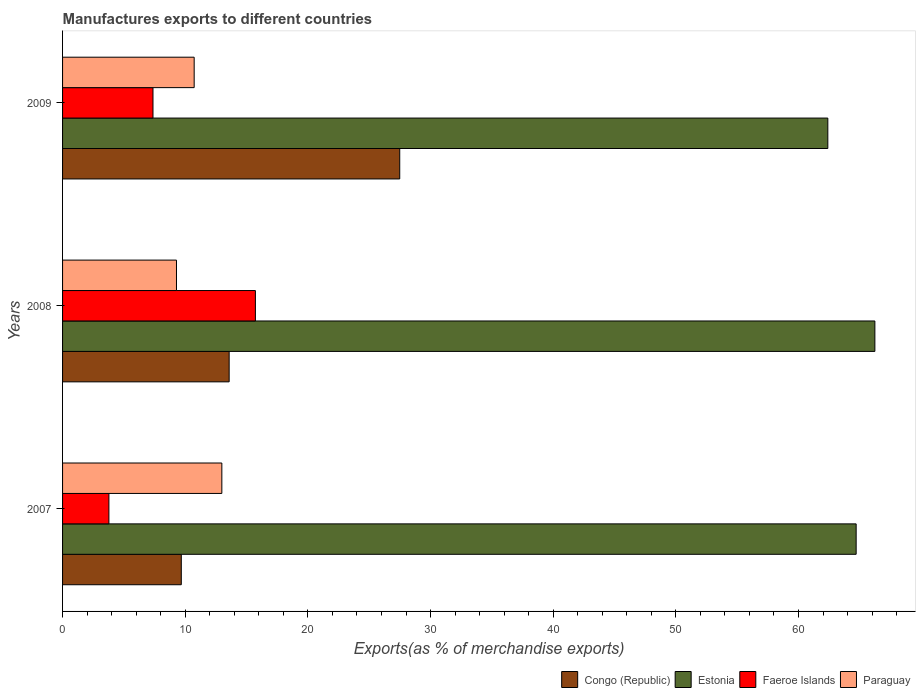How many different coloured bars are there?
Ensure brevity in your answer.  4. Are the number of bars on each tick of the Y-axis equal?
Give a very brief answer. Yes. How many bars are there on the 1st tick from the bottom?
Ensure brevity in your answer.  4. What is the label of the 1st group of bars from the top?
Provide a succinct answer. 2009. What is the percentage of exports to different countries in Congo (Republic) in 2007?
Your answer should be compact. 9.68. Across all years, what is the maximum percentage of exports to different countries in Congo (Republic)?
Your answer should be compact. 27.49. Across all years, what is the minimum percentage of exports to different countries in Congo (Republic)?
Keep it short and to the point. 9.68. In which year was the percentage of exports to different countries in Faeroe Islands maximum?
Your answer should be compact. 2008. What is the total percentage of exports to different countries in Paraguay in the graph?
Your answer should be compact. 33. What is the difference between the percentage of exports to different countries in Estonia in 2007 and that in 2009?
Make the answer very short. 2.31. What is the difference between the percentage of exports to different countries in Congo (Republic) in 2009 and the percentage of exports to different countries in Paraguay in 2007?
Provide a succinct answer. 14.5. What is the average percentage of exports to different countries in Faeroe Islands per year?
Keep it short and to the point. 8.96. In the year 2009, what is the difference between the percentage of exports to different countries in Faeroe Islands and percentage of exports to different countries in Estonia?
Keep it short and to the point. -55.02. What is the ratio of the percentage of exports to different countries in Faeroe Islands in 2007 to that in 2009?
Keep it short and to the point. 0.51. Is the percentage of exports to different countries in Paraguay in 2008 less than that in 2009?
Provide a succinct answer. Yes. Is the difference between the percentage of exports to different countries in Faeroe Islands in 2008 and 2009 greater than the difference between the percentage of exports to different countries in Estonia in 2008 and 2009?
Provide a short and direct response. Yes. What is the difference between the highest and the second highest percentage of exports to different countries in Congo (Republic)?
Your answer should be compact. 13.91. What is the difference between the highest and the lowest percentage of exports to different countries in Estonia?
Offer a terse response. 3.84. Is the sum of the percentage of exports to different countries in Congo (Republic) in 2007 and 2008 greater than the maximum percentage of exports to different countries in Paraguay across all years?
Your answer should be very brief. Yes. Is it the case that in every year, the sum of the percentage of exports to different countries in Congo (Republic) and percentage of exports to different countries in Estonia is greater than the sum of percentage of exports to different countries in Faeroe Islands and percentage of exports to different countries in Paraguay?
Make the answer very short. No. What does the 2nd bar from the top in 2009 represents?
Offer a very short reply. Faeroe Islands. What does the 1st bar from the bottom in 2009 represents?
Keep it short and to the point. Congo (Republic). Is it the case that in every year, the sum of the percentage of exports to different countries in Congo (Republic) and percentage of exports to different countries in Paraguay is greater than the percentage of exports to different countries in Faeroe Islands?
Provide a short and direct response. Yes. How many bars are there?
Your response must be concise. 12. Are the values on the major ticks of X-axis written in scientific E-notation?
Keep it short and to the point. No. Does the graph contain grids?
Offer a very short reply. No. How many legend labels are there?
Your answer should be very brief. 4. What is the title of the graph?
Offer a terse response. Manufactures exports to different countries. What is the label or title of the X-axis?
Offer a very short reply. Exports(as % of merchandise exports). What is the Exports(as % of merchandise exports) of Congo (Republic) in 2007?
Give a very brief answer. 9.68. What is the Exports(as % of merchandise exports) of Estonia in 2007?
Your response must be concise. 64.7. What is the Exports(as % of merchandise exports) of Faeroe Islands in 2007?
Make the answer very short. 3.78. What is the Exports(as % of merchandise exports) in Paraguay in 2007?
Your response must be concise. 12.99. What is the Exports(as % of merchandise exports) in Congo (Republic) in 2008?
Your response must be concise. 13.58. What is the Exports(as % of merchandise exports) in Estonia in 2008?
Your answer should be very brief. 66.23. What is the Exports(as % of merchandise exports) in Faeroe Islands in 2008?
Provide a succinct answer. 15.72. What is the Exports(as % of merchandise exports) in Paraguay in 2008?
Your answer should be very brief. 9.29. What is the Exports(as % of merchandise exports) in Congo (Republic) in 2009?
Your response must be concise. 27.49. What is the Exports(as % of merchandise exports) in Estonia in 2009?
Make the answer very short. 62.39. What is the Exports(as % of merchandise exports) of Faeroe Islands in 2009?
Provide a succinct answer. 7.37. What is the Exports(as % of merchandise exports) of Paraguay in 2009?
Offer a terse response. 10.73. Across all years, what is the maximum Exports(as % of merchandise exports) of Congo (Republic)?
Offer a very short reply. 27.49. Across all years, what is the maximum Exports(as % of merchandise exports) in Estonia?
Your response must be concise. 66.23. Across all years, what is the maximum Exports(as % of merchandise exports) in Faeroe Islands?
Provide a succinct answer. 15.72. Across all years, what is the maximum Exports(as % of merchandise exports) of Paraguay?
Your answer should be very brief. 12.99. Across all years, what is the minimum Exports(as % of merchandise exports) in Congo (Republic)?
Make the answer very short. 9.68. Across all years, what is the minimum Exports(as % of merchandise exports) of Estonia?
Your response must be concise. 62.39. Across all years, what is the minimum Exports(as % of merchandise exports) in Faeroe Islands?
Offer a very short reply. 3.78. Across all years, what is the minimum Exports(as % of merchandise exports) in Paraguay?
Provide a succinct answer. 9.29. What is the total Exports(as % of merchandise exports) of Congo (Republic) in the graph?
Make the answer very short. 50.75. What is the total Exports(as % of merchandise exports) in Estonia in the graph?
Your answer should be compact. 193.32. What is the total Exports(as % of merchandise exports) of Faeroe Islands in the graph?
Your response must be concise. 26.87. What is the total Exports(as % of merchandise exports) in Paraguay in the graph?
Offer a terse response. 33. What is the difference between the Exports(as % of merchandise exports) in Congo (Republic) in 2007 and that in 2008?
Provide a short and direct response. -3.9. What is the difference between the Exports(as % of merchandise exports) in Estonia in 2007 and that in 2008?
Make the answer very short. -1.53. What is the difference between the Exports(as % of merchandise exports) in Faeroe Islands in 2007 and that in 2008?
Your answer should be very brief. -11.94. What is the difference between the Exports(as % of merchandise exports) of Paraguay in 2007 and that in 2008?
Provide a succinct answer. 3.7. What is the difference between the Exports(as % of merchandise exports) of Congo (Republic) in 2007 and that in 2009?
Give a very brief answer. -17.81. What is the difference between the Exports(as % of merchandise exports) in Estonia in 2007 and that in 2009?
Your answer should be very brief. 2.31. What is the difference between the Exports(as % of merchandise exports) of Faeroe Islands in 2007 and that in 2009?
Your answer should be compact. -3.59. What is the difference between the Exports(as % of merchandise exports) in Paraguay in 2007 and that in 2009?
Offer a terse response. 2.26. What is the difference between the Exports(as % of merchandise exports) in Congo (Republic) in 2008 and that in 2009?
Provide a short and direct response. -13.91. What is the difference between the Exports(as % of merchandise exports) in Estonia in 2008 and that in 2009?
Give a very brief answer. 3.84. What is the difference between the Exports(as % of merchandise exports) of Faeroe Islands in 2008 and that in 2009?
Provide a succinct answer. 8.35. What is the difference between the Exports(as % of merchandise exports) in Paraguay in 2008 and that in 2009?
Ensure brevity in your answer.  -1.44. What is the difference between the Exports(as % of merchandise exports) of Congo (Republic) in 2007 and the Exports(as % of merchandise exports) of Estonia in 2008?
Provide a succinct answer. -56.55. What is the difference between the Exports(as % of merchandise exports) in Congo (Republic) in 2007 and the Exports(as % of merchandise exports) in Faeroe Islands in 2008?
Give a very brief answer. -6.04. What is the difference between the Exports(as % of merchandise exports) in Congo (Republic) in 2007 and the Exports(as % of merchandise exports) in Paraguay in 2008?
Your answer should be compact. 0.39. What is the difference between the Exports(as % of merchandise exports) of Estonia in 2007 and the Exports(as % of merchandise exports) of Faeroe Islands in 2008?
Keep it short and to the point. 48.98. What is the difference between the Exports(as % of merchandise exports) of Estonia in 2007 and the Exports(as % of merchandise exports) of Paraguay in 2008?
Your response must be concise. 55.41. What is the difference between the Exports(as % of merchandise exports) in Faeroe Islands in 2007 and the Exports(as % of merchandise exports) in Paraguay in 2008?
Provide a short and direct response. -5.51. What is the difference between the Exports(as % of merchandise exports) of Congo (Republic) in 2007 and the Exports(as % of merchandise exports) of Estonia in 2009?
Offer a terse response. -52.71. What is the difference between the Exports(as % of merchandise exports) in Congo (Republic) in 2007 and the Exports(as % of merchandise exports) in Faeroe Islands in 2009?
Ensure brevity in your answer.  2.31. What is the difference between the Exports(as % of merchandise exports) in Congo (Republic) in 2007 and the Exports(as % of merchandise exports) in Paraguay in 2009?
Your answer should be compact. -1.05. What is the difference between the Exports(as % of merchandise exports) in Estonia in 2007 and the Exports(as % of merchandise exports) in Faeroe Islands in 2009?
Provide a short and direct response. 57.33. What is the difference between the Exports(as % of merchandise exports) in Estonia in 2007 and the Exports(as % of merchandise exports) in Paraguay in 2009?
Your answer should be very brief. 53.97. What is the difference between the Exports(as % of merchandise exports) in Faeroe Islands in 2007 and the Exports(as % of merchandise exports) in Paraguay in 2009?
Ensure brevity in your answer.  -6.95. What is the difference between the Exports(as % of merchandise exports) of Congo (Republic) in 2008 and the Exports(as % of merchandise exports) of Estonia in 2009?
Keep it short and to the point. -48.81. What is the difference between the Exports(as % of merchandise exports) in Congo (Republic) in 2008 and the Exports(as % of merchandise exports) in Faeroe Islands in 2009?
Offer a very short reply. 6.21. What is the difference between the Exports(as % of merchandise exports) of Congo (Republic) in 2008 and the Exports(as % of merchandise exports) of Paraguay in 2009?
Your answer should be compact. 2.85. What is the difference between the Exports(as % of merchandise exports) in Estonia in 2008 and the Exports(as % of merchandise exports) in Faeroe Islands in 2009?
Provide a short and direct response. 58.86. What is the difference between the Exports(as % of merchandise exports) of Estonia in 2008 and the Exports(as % of merchandise exports) of Paraguay in 2009?
Keep it short and to the point. 55.5. What is the difference between the Exports(as % of merchandise exports) of Faeroe Islands in 2008 and the Exports(as % of merchandise exports) of Paraguay in 2009?
Ensure brevity in your answer.  4.99. What is the average Exports(as % of merchandise exports) in Congo (Republic) per year?
Your answer should be very brief. 16.92. What is the average Exports(as % of merchandise exports) of Estonia per year?
Provide a short and direct response. 64.44. What is the average Exports(as % of merchandise exports) in Faeroe Islands per year?
Offer a very short reply. 8.96. What is the average Exports(as % of merchandise exports) in Paraguay per year?
Ensure brevity in your answer.  11. In the year 2007, what is the difference between the Exports(as % of merchandise exports) of Congo (Republic) and Exports(as % of merchandise exports) of Estonia?
Your answer should be compact. -55.02. In the year 2007, what is the difference between the Exports(as % of merchandise exports) in Congo (Republic) and Exports(as % of merchandise exports) in Faeroe Islands?
Provide a short and direct response. 5.9. In the year 2007, what is the difference between the Exports(as % of merchandise exports) in Congo (Republic) and Exports(as % of merchandise exports) in Paraguay?
Provide a short and direct response. -3.31. In the year 2007, what is the difference between the Exports(as % of merchandise exports) of Estonia and Exports(as % of merchandise exports) of Faeroe Islands?
Your answer should be very brief. 60.92. In the year 2007, what is the difference between the Exports(as % of merchandise exports) in Estonia and Exports(as % of merchandise exports) in Paraguay?
Ensure brevity in your answer.  51.72. In the year 2007, what is the difference between the Exports(as % of merchandise exports) in Faeroe Islands and Exports(as % of merchandise exports) in Paraguay?
Provide a short and direct response. -9.21. In the year 2008, what is the difference between the Exports(as % of merchandise exports) of Congo (Republic) and Exports(as % of merchandise exports) of Estonia?
Your answer should be compact. -52.65. In the year 2008, what is the difference between the Exports(as % of merchandise exports) in Congo (Republic) and Exports(as % of merchandise exports) in Faeroe Islands?
Keep it short and to the point. -2.14. In the year 2008, what is the difference between the Exports(as % of merchandise exports) in Congo (Republic) and Exports(as % of merchandise exports) in Paraguay?
Keep it short and to the point. 4.29. In the year 2008, what is the difference between the Exports(as % of merchandise exports) in Estonia and Exports(as % of merchandise exports) in Faeroe Islands?
Make the answer very short. 50.51. In the year 2008, what is the difference between the Exports(as % of merchandise exports) in Estonia and Exports(as % of merchandise exports) in Paraguay?
Your answer should be compact. 56.94. In the year 2008, what is the difference between the Exports(as % of merchandise exports) in Faeroe Islands and Exports(as % of merchandise exports) in Paraguay?
Ensure brevity in your answer.  6.44. In the year 2009, what is the difference between the Exports(as % of merchandise exports) of Congo (Republic) and Exports(as % of merchandise exports) of Estonia?
Ensure brevity in your answer.  -34.9. In the year 2009, what is the difference between the Exports(as % of merchandise exports) of Congo (Republic) and Exports(as % of merchandise exports) of Faeroe Islands?
Give a very brief answer. 20.12. In the year 2009, what is the difference between the Exports(as % of merchandise exports) in Congo (Republic) and Exports(as % of merchandise exports) in Paraguay?
Give a very brief answer. 16.76. In the year 2009, what is the difference between the Exports(as % of merchandise exports) in Estonia and Exports(as % of merchandise exports) in Faeroe Islands?
Keep it short and to the point. 55.02. In the year 2009, what is the difference between the Exports(as % of merchandise exports) of Estonia and Exports(as % of merchandise exports) of Paraguay?
Provide a short and direct response. 51.66. In the year 2009, what is the difference between the Exports(as % of merchandise exports) of Faeroe Islands and Exports(as % of merchandise exports) of Paraguay?
Your answer should be compact. -3.36. What is the ratio of the Exports(as % of merchandise exports) in Congo (Republic) in 2007 to that in 2008?
Provide a short and direct response. 0.71. What is the ratio of the Exports(as % of merchandise exports) of Estonia in 2007 to that in 2008?
Ensure brevity in your answer.  0.98. What is the ratio of the Exports(as % of merchandise exports) of Faeroe Islands in 2007 to that in 2008?
Offer a terse response. 0.24. What is the ratio of the Exports(as % of merchandise exports) of Paraguay in 2007 to that in 2008?
Provide a succinct answer. 1.4. What is the ratio of the Exports(as % of merchandise exports) in Congo (Republic) in 2007 to that in 2009?
Provide a short and direct response. 0.35. What is the ratio of the Exports(as % of merchandise exports) of Estonia in 2007 to that in 2009?
Provide a short and direct response. 1.04. What is the ratio of the Exports(as % of merchandise exports) in Faeroe Islands in 2007 to that in 2009?
Your answer should be very brief. 0.51. What is the ratio of the Exports(as % of merchandise exports) in Paraguay in 2007 to that in 2009?
Keep it short and to the point. 1.21. What is the ratio of the Exports(as % of merchandise exports) in Congo (Republic) in 2008 to that in 2009?
Your response must be concise. 0.49. What is the ratio of the Exports(as % of merchandise exports) in Estonia in 2008 to that in 2009?
Keep it short and to the point. 1.06. What is the ratio of the Exports(as % of merchandise exports) of Faeroe Islands in 2008 to that in 2009?
Offer a very short reply. 2.13. What is the ratio of the Exports(as % of merchandise exports) of Paraguay in 2008 to that in 2009?
Offer a very short reply. 0.87. What is the difference between the highest and the second highest Exports(as % of merchandise exports) in Congo (Republic)?
Ensure brevity in your answer.  13.91. What is the difference between the highest and the second highest Exports(as % of merchandise exports) in Estonia?
Your answer should be compact. 1.53. What is the difference between the highest and the second highest Exports(as % of merchandise exports) in Faeroe Islands?
Your response must be concise. 8.35. What is the difference between the highest and the second highest Exports(as % of merchandise exports) in Paraguay?
Keep it short and to the point. 2.26. What is the difference between the highest and the lowest Exports(as % of merchandise exports) of Congo (Republic)?
Give a very brief answer. 17.81. What is the difference between the highest and the lowest Exports(as % of merchandise exports) of Estonia?
Make the answer very short. 3.84. What is the difference between the highest and the lowest Exports(as % of merchandise exports) of Faeroe Islands?
Offer a very short reply. 11.94. What is the difference between the highest and the lowest Exports(as % of merchandise exports) of Paraguay?
Provide a short and direct response. 3.7. 